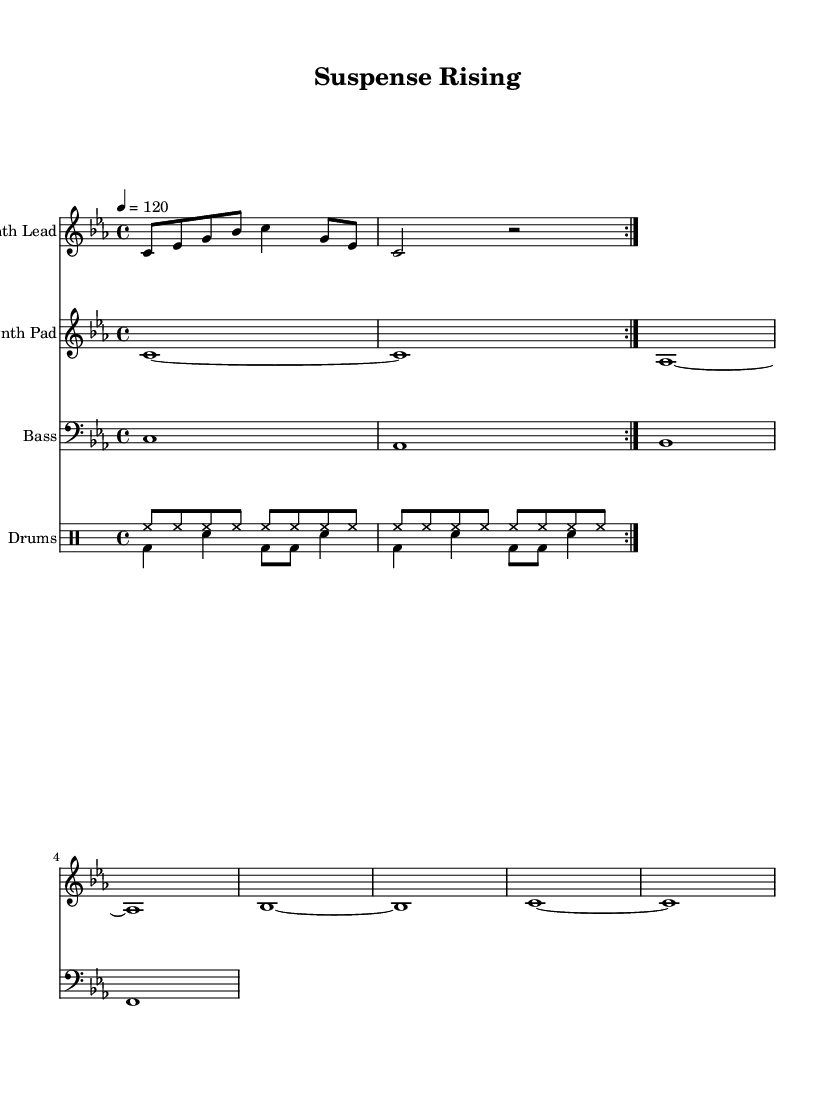What is the key signature of this music? The key signature is C minor, which has three flats (B♭, E♭, A♭). It can be identified by looking at the key signature in the beginning of the staff where the note symbols indicate the flats.
Answer: C minor What is the time signature of the piece? The time signature is 4/4, which indicates that there are four beats in each measure and the quarter note receives one beat. This can be seen at the beginning of the score where the time signature is indicated.
Answer: 4/4 What is the tempo marking of the music? The tempo marking is 120 beats per minute, which means the piece should be played at a pace that gives 120 beats in one minute. This is specifically noted in the score below the key signature.
Answer: 120 How many measures are present in the synth lead section? The synth lead section has a total of 4 measures, which can be counted by looking at the grouping of the notes and the separation between the repeated sections. Each repeat counts towards the total as it represents the same measures played again.
Answer: 4 What elements contribute to the suspenseful nature of this music? The suspenseful nature mainly comes from the combination of the synth lead's escalating melody, the deep bass notes that create tension, and the driving rhythm of the drums. Observing how these elements interact showcases the build-up characteristic of cinematic music designed for suspense.
Answer: Synth lead, bass, drums What type of drum pattern is used in this score? The drum pattern consists of hi-hat and bass drum beats with snare strikes interspersed, creating a driving rhythmic feel typical in dance music that keeps the energy up while also building tension. This can be identified by analyzing the rhythmic structure and instruments notated in the drum section.
Answer: Hi-hat and bass drum with snare 